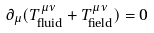<formula> <loc_0><loc_0><loc_500><loc_500>\partial _ { \mu } ( T _ { \text {fluid} } ^ { \mu \nu } + T _ { \text {field} } ^ { \mu \nu } ) = 0</formula> 